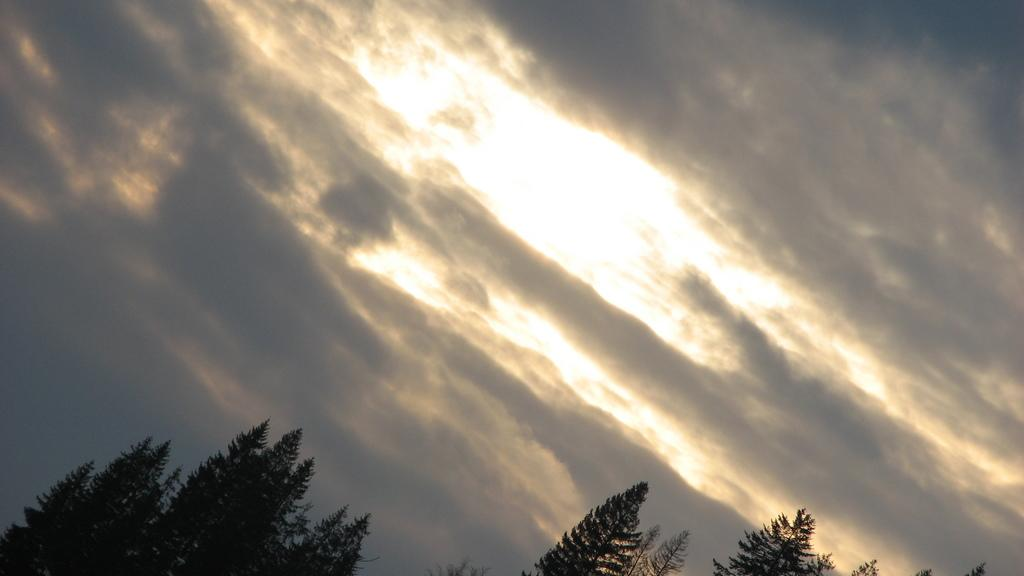What type of vegetation is at the bottom of the image? There are trees at the bottom of the image. What part of the natural environment is visible in the image? The sky is visible in the background of the image. Can you describe the weather condition in the image? The sky appears to be cloudy in the image. What type of brick structure can be seen in the image? There is no brick structure present in the image; it features trees and a cloudy sky. What financial interest is depicted in the image? There is no financial interest depicted in the image; it features trees and a cloudy sky. 